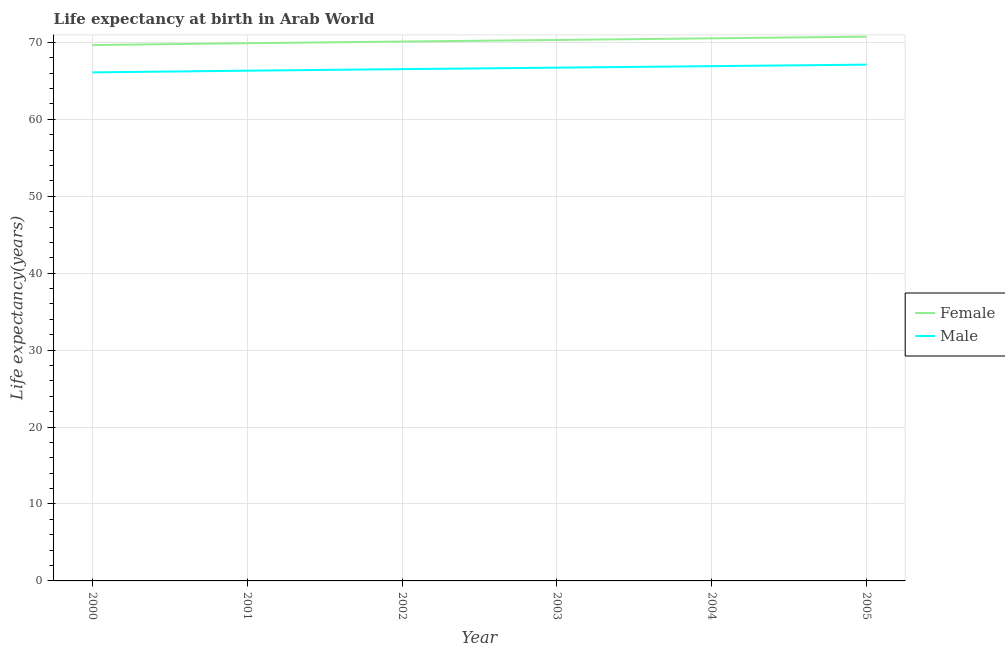How many different coloured lines are there?
Keep it short and to the point. 2. Is the number of lines equal to the number of legend labels?
Provide a succinct answer. Yes. What is the life expectancy(male) in 2003?
Your answer should be very brief. 66.71. Across all years, what is the maximum life expectancy(female)?
Offer a very short reply. 70.74. Across all years, what is the minimum life expectancy(male)?
Provide a short and direct response. 66.1. In which year was the life expectancy(male) minimum?
Keep it short and to the point. 2000. What is the total life expectancy(male) in the graph?
Offer a very short reply. 399.68. What is the difference between the life expectancy(female) in 2004 and that in 2005?
Provide a succinct answer. -0.22. What is the difference between the life expectancy(male) in 2000 and the life expectancy(female) in 2001?
Offer a very short reply. -3.79. What is the average life expectancy(male) per year?
Keep it short and to the point. 66.61. In the year 2003, what is the difference between the life expectancy(male) and life expectancy(female)?
Offer a terse response. -3.6. In how many years, is the life expectancy(male) greater than 32 years?
Your response must be concise. 6. What is the ratio of the life expectancy(male) in 2001 to that in 2002?
Give a very brief answer. 1. Is the life expectancy(male) in 2000 less than that in 2005?
Your response must be concise. Yes. Is the difference between the life expectancy(female) in 2003 and 2004 greater than the difference between the life expectancy(male) in 2003 and 2004?
Provide a short and direct response. No. What is the difference between the highest and the second highest life expectancy(male)?
Keep it short and to the point. 0.2. What is the difference between the highest and the lowest life expectancy(male)?
Provide a short and direct response. 1. Is the life expectancy(female) strictly greater than the life expectancy(male) over the years?
Ensure brevity in your answer.  Yes. How many lines are there?
Your response must be concise. 2. Are the values on the major ticks of Y-axis written in scientific E-notation?
Keep it short and to the point. No. Where does the legend appear in the graph?
Give a very brief answer. Center right. How are the legend labels stacked?
Make the answer very short. Vertical. What is the title of the graph?
Offer a very short reply. Life expectancy at birth in Arab World. What is the label or title of the Y-axis?
Give a very brief answer. Life expectancy(years). What is the Life expectancy(years) of Female in 2000?
Your response must be concise. 69.65. What is the Life expectancy(years) of Male in 2000?
Your answer should be compact. 66.1. What is the Life expectancy(years) in Female in 2001?
Ensure brevity in your answer.  69.89. What is the Life expectancy(years) in Male in 2001?
Provide a short and direct response. 66.32. What is the Life expectancy(years) of Female in 2002?
Your answer should be very brief. 70.11. What is the Life expectancy(years) in Male in 2002?
Your response must be concise. 66.52. What is the Life expectancy(years) in Female in 2003?
Keep it short and to the point. 70.32. What is the Life expectancy(years) in Male in 2003?
Offer a terse response. 66.71. What is the Life expectancy(years) of Female in 2004?
Offer a terse response. 70.53. What is the Life expectancy(years) of Male in 2004?
Keep it short and to the point. 66.91. What is the Life expectancy(years) of Female in 2005?
Offer a very short reply. 70.74. What is the Life expectancy(years) in Male in 2005?
Provide a short and direct response. 67.11. Across all years, what is the maximum Life expectancy(years) of Female?
Offer a terse response. 70.74. Across all years, what is the maximum Life expectancy(years) in Male?
Your response must be concise. 67.11. Across all years, what is the minimum Life expectancy(years) of Female?
Provide a succinct answer. 69.65. Across all years, what is the minimum Life expectancy(years) of Male?
Ensure brevity in your answer.  66.1. What is the total Life expectancy(years) of Female in the graph?
Your answer should be compact. 421.24. What is the total Life expectancy(years) in Male in the graph?
Ensure brevity in your answer.  399.68. What is the difference between the Life expectancy(years) in Female in 2000 and that in 2001?
Your answer should be very brief. -0.24. What is the difference between the Life expectancy(years) in Male in 2000 and that in 2001?
Your answer should be very brief. -0.22. What is the difference between the Life expectancy(years) in Female in 2000 and that in 2002?
Ensure brevity in your answer.  -0.46. What is the difference between the Life expectancy(years) of Male in 2000 and that in 2002?
Give a very brief answer. -0.42. What is the difference between the Life expectancy(years) of Female in 2000 and that in 2003?
Your answer should be compact. -0.66. What is the difference between the Life expectancy(years) of Male in 2000 and that in 2003?
Make the answer very short. -0.61. What is the difference between the Life expectancy(years) of Female in 2000 and that in 2004?
Provide a short and direct response. -0.88. What is the difference between the Life expectancy(years) of Male in 2000 and that in 2004?
Your answer should be compact. -0.81. What is the difference between the Life expectancy(years) of Female in 2000 and that in 2005?
Provide a short and direct response. -1.09. What is the difference between the Life expectancy(years) in Male in 2000 and that in 2005?
Your response must be concise. -1. What is the difference between the Life expectancy(years) of Female in 2001 and that in 2002?
Keep it short and to the point. -0.22. What is the difference between the Life expectancy(years) of Male in 2001 and that in 2002?
Keep it short and to the point. -0.2. What is the difference between the Life expectancy(years) of Female in 2001 and that in 2003?
Offer a very short reply. -0.42. What is the difference between the Life expectancy(years) in Male in 2001 and that in 2003?
Provide a succinct answer. -0.39. What is the difference between the Life expectancy(years) in Female in 2001 and that in 2004?
Offer a terse response. -0.64. What is the difference between the Life expectancy(years) in Male in 2001 and that in 2004?
Ensure brevity in your answer.  -0.59. What is the difference between the Life expectancy(years) of Female in 2001 and that in 2005?
Provide a short and direct response. -0.85. What is the difference between the Life expectancy(years) in Male in 2001 and that in 2005?
Provide a succinct answer. -0.79. What is the difference between the Life expectancy(years) of Female in 2002 and that in 2003?
Give a very brief answer. -0.21. What is the difference between the Life expectancy(years) in Male in 2002 and that in 2003?
Give a very brief answer. -0.19. What is the difference between the Life expectancy(years) of Female in 2002 and that in 2004?
Your answer should be very brief. -0.42. What is the difference between the Life expectancy(years) in Male in 2002 and that in 2004?
Keep it short and to the point. -0.39. What is the difference between the Life expectancy(years) in Female in 2002 and that in 2005?
Your answer should be very brief. -0.64. What is the difference between the Life expectancy(years) in Male in 2002 and that in 2005?
Make the answer very short. -0.58. What is the difference between the Life expectancy(years) in Female in 2003 and that in 2004?
Your response must be concise. -0.21. What is the difference between the Life expectancy(years) in Male in 2003 and that in 2004?
Keep it short and to the point. -0.2. What is the difference between the Life expectancy(years) of Female in 2003 and that in 2005?
Your answer should be very brief. -0.43. What is the difference between the Life expectancy(years) in Male in 2003 and that in 2005?
Provide a short and direct response. -0.39. What is the difference between the Life expectancy(years) in Female in 2004 and that in 2005?
Ensure brevity in your answer.  -0.22. What is the difference between the Life expectancy(years) of Male in 2004 and that in 2005?
Your answer should be compact. -0.2. What is the difference between the Life expectancy(years) of Female in 2000 and the Life expectancy(years) of Male in 2001?
Ensure brevity in your answer.  3.33. What is the difference between the Life expectancy(years) of Female in 2000 and the Life expectancy(years) of Male in 2002?
Provide a succinct answer. 3.13. What is the difference between the Life expectancy(years) in Female in 2000 and the Life expectancy(years) in Male in 2003?
Give a very brief answer. 2.94. What is the difference between the Life expectancy(years) of Female in 2000 and the Life expectancy(years) of Male in 2004?
Your response must be concise. 2.74. What is the difference between the Life expectancy(years) of Female in 2000 and the Life expectancy(years) of Male in 2005?
Provide a succinct answer. 2.55. What is the difference between the Life expectancy(years) of Female in 2001 and the Life expectancy(years) of Male in 2002?
Your response must be concise. 3.37. What is the difference between the Life expectancy(years) in Female in 2001 and the Life expectancy(years) in Male in 2003?
Provide a short and direct response. 3.18. What is the difference between the Life expectancy(years) in Female in 2001 and the Life expectancy(years) in Male in 2004?
Keep it short and to the point. 2.98. What is the difference between the Life expectancy(years) of Female in 2001 and the Life expectancy(years) of Male in 2005?
Your response must be concise. 2.78. What is the difference between the Life expectancy(years) in Female in 2002 and the Life expectancy(years) in Male in 2003?
Give a very brief answer. 3.39. What is the difference between the Life expectancy(years) of Female in 2002 and the Life expectancy(years) of Male in 2004?
Your answer should be very brief. 3.2. What is the difference between the Life expectancy(years) in Female in 2002 and the Life expectancy(years) in Male in 2005?
Provide a succinct answer. 3. What is the difference between the Life expectancy(years) in Female in 2003 and the Life expectancy(years) in Male in 2004?
Make the answer very short. 3.41. What is the difference between the Life expectancy(years) in Female in 2003 and the Life expectancy(years) in Male in 2005?
Offer a terse response. 3.21. What is the difference between the Life expectancy(years) of Female in 2004 and the Life expectancy(years) of Male in 2005?
Provide a short and direct response. 3.42. What is the average Life expectancy(years) of Female per year?
Offer a very short reply. 70.21. What is the average Life expectancy(years) in Male per year?
Give a very brief answer. 66.61. In the year 2000, what is the difference between the Life expectancy(years) in Female and Life expectancy(years) in Male?
Ensure brevity in your answer.  3.55. In the year 2001, what is the difference between the Life expectancy(years) in Female and Life expectancy(years) in Male?
Provide a succinct answer. 3.57. In the year 2002, what is the difference between the Life expectancy(years) of Female and Life expectancy(years) of Male?
Your answer should be very brief. 3.58. In the year 2003, what is the difference between the Life expectancy(years) in Female and Life expectancy(years) in Male?
Offer a terse response. 3.6. In the year 2004, what is the difference between the Life expectancy(years) in Female and Life expectancy(years) in Male?
Offer a terse response. 3.62. In the year 2005, what is the difference between the Life expectancy(years) of Female and Life expectancy(years) of Male?
Provide a succinct answer. 3.64. What is the ratio of the Life expectancy(years) in Female in 2000 to that in 2001?
Offer a terse response. 1. What is the ratio of the Life expectancy(years) in Male in 2000 to that in 2001?
Offer a terse response. 1. What is the ratio of the Life expectancy(years) in Female in 2000 to that in 2002?
Your answer should be very brief. 0.99. What is the ratio of the Life expectancy(years) of Male in 2000 to that in 2002?
Your answer should be very brief. 0.99. What is the ratio of the Life expectancy(years) of Female in 2000 to that in 2003?
Your response must be concise. 0.99. What is the ratio of the Life expectancy(years) of Male in 2000 to that in 2003?
Offer a terse response. 0.99. What is the ratio of the Life expectancy(years) in Female in 2000 to that in 2004?
Offer a very short reply. 0.99. What is the ratio of the Life expectancy(years) of Male in 2000 to that in 2004?
Provide a succinct answer. 0.99. What is the ratio of the Life expectancy(years) in Female in 2000 to that in 2005?
Ensure brevity in your answer.  0.98. What is the ratio of the Life expectancy(years) in Female in 2001 to that in 2003?
Provide a succinct answer. 0.99. What is the ratio of the Life expectancy(years) in Male in 2001 to that in 2004?
Your response must be concise. 0.99. What is the ratio of the Life expectancy(years) in Female in 2001 to that in 2005?
Your answer should be compact. 0.99. What is the ratio of the Life expectancy(years) of Male in 2001 to that in 2005?
Keep it short and to the point. 0.99. What is the ratio of the Life expectancy(years) of Female in 2002 to that in 2003?
Your response must be concise. 1. What is the ratio of the Life expectancy(years) of Male in 2002 to that in 2003?
Make the answer very short. 1. What is the ratio of the Life expectancy(years) in Female in 2002 to that in 2004?
Provide a short and direct response. 0.99. What is the ratio of the Life expectancy(years) in Male in 2003 to that in 2004?
Offer a terse response. 1. What is the ratio of the Life expectancy(years) in Male in 2003 to that in 2005?
Ensure brevity in your answer.  0.99. What is the ratio of the Life expectancy(years) of Female in 2004 to that in 2005?
Your answer should be very brief. 1. What is the ratio of the Life expectancy(years) in Male in 2004 to that in 2005?
Offer a very short reply. 1. What is the difference between the highest and the second highest Life expectancy(years) in Female?
Your response must be concise. 0.22. What is the difference between the highest and the second highest Life expectancy(years) of Male?
Give a very brief answer. 0.2. What is the difference between the highest and the lowest Life expectancy(years) in Female?
Offer a very short reply. 1.09. What is the difference between the highest and the lowest Life expectancy(years) of Male?
Offer a very short reply. 1. 